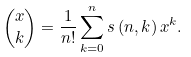Convert formula to latex. <formula><loc_0><loc_0><loc_500><loc_500>\binom { x } { k } = \frac { 1 } { n ! } \sum _ { k = 0 } ^ { n } s \left ( n , k \right ) x ^ { k } .</formula> 